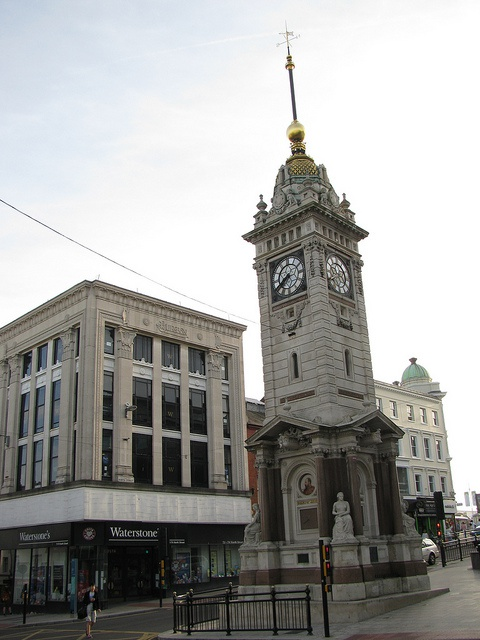Describe the objects in this image and their specific colors. I can see clock in lightgray, gray, darkgray, and black tones, clock in lightgray, gray, darkgray, and black tones, people in lightgray, black, gray, maroon, and darkgreen tones, car in lightgray, gray, black, ivory, and darkgray tones, and people in black, darkgreen, and lightgray tones in this image. 